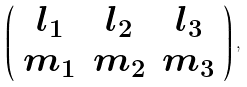Convert formula to latex. <formula><loc_0><loc_0><loc_500><loc_500>\left ( \begin{array} { c c c } l _ { 1 } & l _ { 2 } & l _ { 3 } \\ m _ { 1 } & m _ { 2 } & m _ { 3 } \end{array} \right ) ,</formula> 